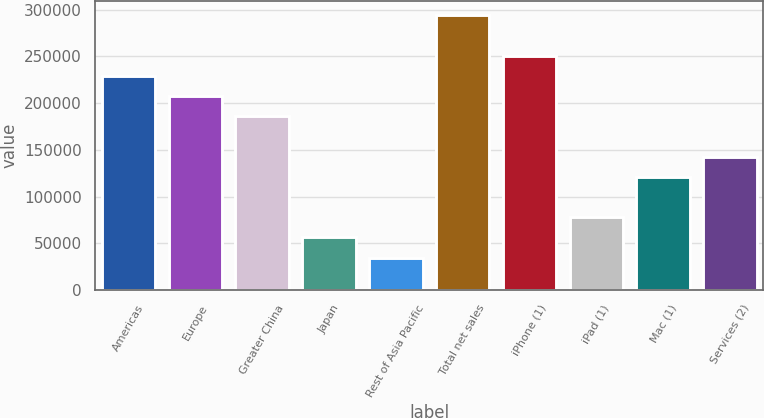<chart> <loc_0><loc_0><loc_500><loc_500><bar_chart><fcel>Americas<fcel>Europe<fcel>Greater China<fcel>Japan<fcel>Rest of Asia Pacific<fcel>Total net sales<fcel>iPhone (1)<fcel>iPad (1)<fcel>Mac (1)<fcel>Services (2)<nl><fcel>229234<fcel>207597<fcel>185960<fcel>56137.2<fcel>34500.1<fcel>294145<fcel>250871<fcel>77774.3<fcel>121048<fcel>142686<nl></chart> 